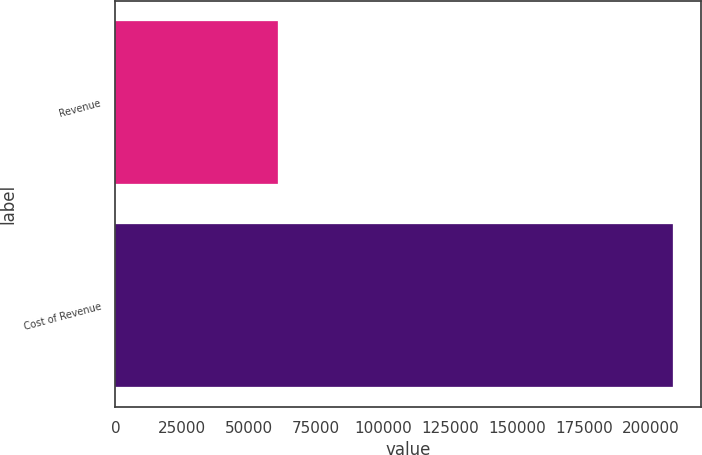Convert chart. <chart><loc_0><loc_0><loc_500><loc_500><bar_chart><fcel>Revenue<fcel>Cost of Revenue<nl><fcel>60749<fcel>208329<nl></chart> 